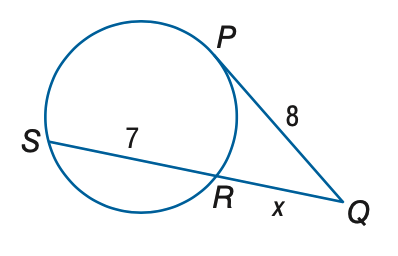Answer the mathemtical geometry problem and directly provide the correct option letter.
Question: P Q is tangent to the circle. Find x. Round to the nearest tenth.
Choices: A: 4.2 B: 5.2 C: 6.2 D: 7.2 B 